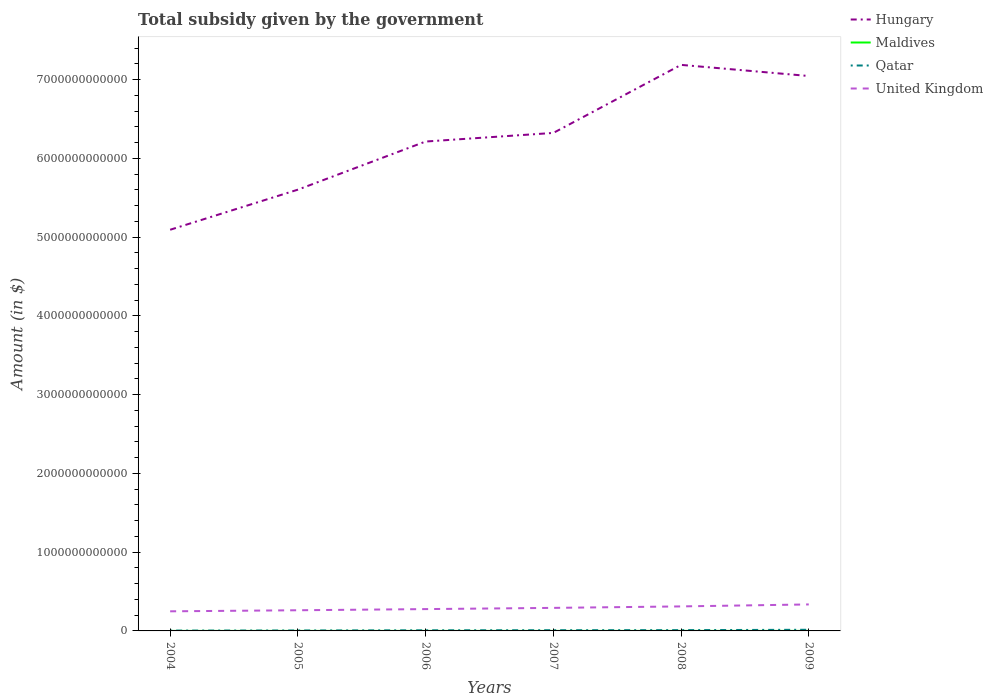How many different coloured lines are there?
Offer a terse response. 4. Does the line corresponding to Maldives intersect with the line corresponding to United Kingdom?
Give a very brief answer. No. Across all years, what is the maximum total revenue collected by the government in Hungary?
Offer a terse response. 5.09e+12. What is the total total revenue collected by the government in United Kingdom in the graph?
Offer a terse response. -3.41e+1. What is the difference between the highest and the second highest total revenue collected by the government in Qatar?
Your answer should be very brief. 1.04e+1. Is the total revenue collected by the government in United Kingdom strictly greater than the total revenue collected by the government in Hungary over the years?
Your response must be concise. Yes. How many lines are there?
Your answer should be very brief. 4. What is the difference between two consecutive major ticks on the Y-axis?
Your response must be concise. 1.00e+12. Are the values on the major ticks of Y-axis written in scientific E-notation?
Offer a terse response. No. Does the graph contain any zero values?
Provide a succinct answer. No. Where does the legend appear in the graph?
Provide a succinct answer. Top right. How many legend labels are there?
Offer a very short reply. 4. What is the title of the graph?
Your answer should be very brief. Total subsidy given by the government. What is the label or title of the X-axis?
Offer a terse response. Years. What is the label or title of the Y-axis?
Keep it short and to the point. Amount (in $). What is the Amount (in $) in Hungary in 2004?
Keep it short and to the point. 5.09e+12. What is the Amount (in $) in Maldives in 2004?
Your answer should be very brief. 4.87e+07. What is the Amount (in $) in Qatar in 2004?
Offer a terse response. 4.11e+09. What is the Amount (in $) in United Kingdom in 2004?
Provide a succinct answer. 2.49e+11. What is the Amount (in $) in Hungary in 2005?
Give a very brief answer. 5.60e+12. What is the Amount (in $) in Maldives in 2005?
Ensure brevity in your answer.  2.28e+08. What is the Amount (in $) in Qatar in 2005?
Your response must be concise. 5.51e+09. What is the Amount (in $) of United Kingdom in 2005?
Offer a very short reply. 2.62e+11. What is the Amount (in $) in Hungary in 2006?
Offer a very short reply. 6.21e+12. What is the Amount (in $) of Maldives in 2006?
Make the answer very short. 1.50e+08. What is the Amount (in $) of Qatar in 2006?
Provide a succinct answer. 7.79e+09. What is the Amount (in $) of United Kingdom in 2006?
Your answer should be compact. 2.77e+11. What is the Amount (in $) in Hungary in 2007?
Provide a short and direct response. 6.32e+12. What is the Amount (in $) of Maldives in 2007?
Your answer should be compact. 1.68e+08. What is the Amount (in $) in Qatar in 2007?
Offer a very short reply. 8.92e+09. What is the Amount (in $) in United Kingdom in 2007?
Give a very brief answer. 2.93e+11. What is the Amount (in $) of Hungary in 2008?
Ensure brevity in your answer.  7.19e+12. What is the Amount (in $) in Maldives in 2008?
Ensure brevity in your answer.  4.79e+08. What is the Amount (in $) of Qatar in 2008?
Provide a short and direct response. 9.95e+09. What is the Amount (in $) of United Kingdom in 2008?
Make the answer very short. 3.11e+11. What is the Amount (in $) of Hungary in 2009?
Offer a terse response. 7.04e+12. What is the Amount (in $) of Maldives in 2009?
Provide a succinct answer. 4.22e+08. What is the Amount (in $) in Qatar in 2009?
Your response must be concise. 1.45e+1. What is the Amount (in $) of United Kingdom in 2009?
Offer a terse response. 3.36e+11. Across all years, what is the maximum Amount (in $) of Hungary?
Give a very brief answer. 7.19e+12. Across all years, what is the maximum Amount (in $) in Maldives?
Give a very brief answer. 4.79e+08. Across all years, what is the maximum Amount (in $) of Qatar?
Offer a very short reply. 1.45e+1. Across all years, what is the maximum Amount (in $) in United Kingdom?
Your response must be concise. 3.36e+11. Across all years, what is the minimum Amount (in $) in Hungary?
Your answer should be very brief. 5.09e+12. Across all years, what is the minimum Amount (in $) in Maldives?
Your answer should be compact. 4.87e+07. Across all years, what is the minimum Amount (in $) in Qatar?
Your answer should be compact. 4.11e+09. Across all years, what is the minimum Amount (in $) of United Kingdom?
Your answer should be very brief. 2.49e+11. What is the total Amount (in $) in Hungary in the graph?
Your answer should be compact. 3.75e+13. What is the total Amount (in $) in Maldives in the graph?
Offer a very short reply. 1.50e+09. What is the total Amount (in $) in Qatar in the graph?
Your answer should be very brief. 5.08e+1. What is the total Amount (in $) of United Kingdom in the graph?
Provide a succinct answer. 1.73e+12. What is the difference between the Amount (in $) in Hungary in 2004 and that in 2005?
Provide a succinct answer. -5.09e+11. What is the difference between the Amount (in $) in Maldives in 2004 and that in 2005?
Offer a very short reply. -1.79e+08. What is the difference between the Amount (in $) in Qatar in 2004 and that in 2005?
Keep it short and to the point. -1.41e+09. What is the difference between the Amount (in $) in United Kingdom in 2004 and that in 2005?
Make the answer very short. -1.35e+1. What is the difference between the Amount (in $) in Hungary in 2004 and that in 2006?
Your response must be concise. -1.12e+12. What is the difference between the Amount (in $) in Maldives in 2004 and that in 2006?
Make the answer very short. -1.01e+08. What is the difference between the Amount (in $) in Qatar in 2004 and that in 2006?
Offer a terse response. -3.68e+09. What is the difference between the Amount (in $) in United Kingdom in 2004 and that in 2006?
Ensure brevity in your answer.  -2.82e+1. What is the difference between the Amount (in $) in Hungary in 2004 and that in 2007?
Your answer should be very brief. -1.23e+12. What is the difference between the Amount (in $) of Maldives in 2004 and that in 2007?
Provide a succinct answer. -1.20e+08. What is the difference between the Amount (in $) of Qatar in 2004 and that in 2007?
Provide a short and direct response. -4.81e+09. What is the difference between the Amount (in $) of United Kingdom in 2004 and that in 2007?
Your response must be concise. -4.36e+1. What is the difference between the Amount (in $) of Hungary in 2004 and that in 2008?
Your answer should be very brief. -2.09e+12. What is the difference between the Amount (in $) in Maldives in 2004 and that in 2008?
Make the answer very short. -4.30e+08. What is the difference between the Amount (in $) of Qatar in 2004 and that in 2008?
Offer a terse response. -5.85e+09. What is the difference between the Amount (in $) in United Kingdom in 2004 and that in 2008?
Your answer should be compact. -6.22e+1. What is the difference between the Amount (in $) in Hungary in 2004 and that in 2009?
Provide a short and direct response. -1.95e+12. What is the difference between the Amount (in $) of Maldives in 2004 and that in 2009?
Provide a short and direct response. -3.73e+08. What is the difference between the Amount (in $) of Qatar in 2004 and that in 2009?
Your response must be concise. -1.04e+1. What is the difference between the Amount (in $) of United Kingdom in 2004 and that in 2009?
Offer a very short reply. -8.75e+1. What is the difference between the Amount (in $) in Hungary in 2005 and that in 2006?
Give a very brief answer. -6.11e+11. What is the difference between the Amount (in $) in Maldives in 2005 and that in 2006?
Make the answer very short. 7.77e+07. What is the difference between the Amount (in $) of Qatar in 2005 and that in 2006?
Give a very brief answer. -2.28e+09. What is the difference between the Amount (in $) in United Kingdom in 2005 and that in 2006?
Ensure brevity in your answer.  -1.46e+1. What is the difference between the Amount (in $) of Hungary in 2005 and that in 2007?
Keep it short and to the point. -7.20e+11. What is the difference between the Amount (in $) in Maldives in 2005 and that in 2007?
Your answer should be compact. 5.92e+07. What is the difference between the Amount (in $) of Qatar in 2005 and that in 2007?
Provide a succinct answer. -3.41e+09. What is the difference between the Amount (in $) of United Kingdom in 2005 and that in 2007?
Make the answer very short. -3.01e+1. What is the difference between the Amount (in $) of Hungary in 2005 and that in 2008?
Give a very brief answer. -1.58e+12. What is the difference between the Amount (in $) of Maldives in 2005 and that in 2008?
Your answer should be very brief. -2.52e+08. What is the difference between the Amount (in $) in Qatar in 2005 and that in 2008?
Your answer should be very brief. -4.44e+09. What is the difference between the Amount (in $) of United Kingdom in 2005 and that in 2008?
Offer a terse response. -4.87e+1. What is the difference between the Amount (in $) in Hungary in 2005 and that in 2009?
Ensure brevity in your answer.  -1.44e+12. What is the difference between the Amount (in $) of Maldives in 2005 and that in 2009?
Your response must be concise. -1.94e+08. What is the difference between the Amount (in $) of Qatar in 2005 and that in 2009?
Make the answer very short. -9.03e+09. What is the difference between the Amount (in $) in United Kingdom in 2005 and that in 2009?
Make the answer very short. -7.39e+1. What is the difference between the Amount (in $) in Hungary in 2006 and that in 2007?
Give a very brief answer. -1.09e+11. What is the difference between the Amount (in $) in Maldives in 2006 and that in 2007?
Your answer should be very brief. -1.85e+07. What is the difference between the Amount (in $) in Qatar in 2006 and that in 2007?
Provide a short and direct response. -1.13e+09. What is the difference between the Amount (in $) of United Kingdom in 2006 and that in 2007?
Your response must be concise. -1.55e+1. What is the difference between the Amount (in $) in Hungary in 2006 and that in 2008?
Keep it short and to the point. -9.73e+11. What is the difference between the Amount (in $) of Maldives in 2006 and that in 2008?
Your answer should be very brief. -3.29e+08. What is the difference between the Amount (in $) in Qatar in 2006 and that in 2008?
Your answer should be very brief. -2.16e+09. What is the difference between the Amount (in $) of United Kingdom in 2006 and that in 2008?
Make the answer very short. -3.41e+1. What is the difference between the Amount (in $) in Hungary in 2006 and that in 2009?
Your answer should be very brief. -8.32e+11. What is the difference between the Amount (in $) of Maldives in 2006 and that in 2009?
Offer a very short reply. -2.72e+08. What is the difference between the Amount (in $) in Qatar in 2006 and that in 2009?
Make the answer very short. -6.75e+09. What is the difference between the Amount (in $) in United Kingdom in 2006 and that in 2009?
Make the answer very short. -5.93e+1. What is the difference between the Amount (in $) in Hungary in 2007 and that in 2008?
Keep it short and to the point. -8.64e+11. What is the difference between the Amount (in $) in Maldives in 2007 and that in 2008?
Keep it short and to the point. -3.11e+08. What is the difference between the Amount (in $) of Qatar in 2007 and that in 2008?
Your answer should be very brief. -1.03e+09. What is the difference between the Amount (in $) in United Kingdom in 2007 and that in 2008?
Your answer should be compact. -1.86e+1. What is the difference between the Amount (in $) in Hungary in 2007 and that in 2009?
Provide a short and direct response. -7.23e+11. What is the difference between the Amount (in $) of Maldives in 2007 and that in 2009?
Offer a terse response. -2.53e+08. What is the difference between the Amount (in $) in Qatar in 2007 and that in 2009?
Offer a terse response. -5.62e+09. What is the difference between the Amount (in $) of United Kingdom in 2007 and that in 2009?
Your answer should be compact. -4.38e+1. What is the difference between the Amount (in $) in Hungary in 2008 and that in 2009?
Your answer should be compact. 1.41e+11. What is the difference between the Amount (in $) of Maldives in 2008 and that in 2009?
Offer a very short reply. 5.76e+07. What is the difference between the Amount (in $) of Qatar in 2008 and that in 2009?
Provide a short and direct response. -4.59e+09. What is the difference between the Amount (in $) of United Kingdom in 2008 and that in 2009?
Provide a succinct answer. -2.52e+1. What is the difference between the Amount (in $) of Hungary in 2004 and the Amount (in $) of Maldives in 2005?
Provide a succinct answer. 5.09e+12. What is the difference between the Amount (in $) in Hungary in 2004 and the Amount (in $) in Qatar in 2005?
Your answer should be very brief. 5.09e+12. What is the difference between the Amount (in $) of Hungary in 2004 and the Amount (in $) of United Kingdom in 2005?
Offer a terse response. 4.83e+12. What is the difference between the Amount (in $) of Maldives in 2004 and the Amount (in $) of Qatar in 2005?
Your answer should be very brief. -5.46e+09. What is the difference between the Amount (in $) in Maldives in 2004 and the Amount (in $) in United Kingdom in 2005?
Ensure brevity in your answer.  -2.62e+11. What is the difference between the Amount (in $) of Qatar in 2004 and the Amount (in $) of United Kingdom in 2005?
Offer a very short reply. -2.58e+11. What is the difference between the Amount (in $) in Hungary in 2004 and the Amount (in $) in Maldives in 2006?
Ensure brevity in your answer.  5.09e+12. What is the difference between the Amount (in $) of Hungary in 2004 and the Amount (in $) of Qatar in 2006?
Ensure brevity in your answer.  5.09e+12. What is the difference between the Amount (in $) of Hungary in 2004 and the Amount (in $) of United Kingdom in 2006?
Offer a terse response. 4.82e+12. What is the difference between the Amount (in $) of Maldives in 2004 and the Amount (in $) of Qatar in 2006?
Offer a very short reply. -7.74e+09. What is the difference between the Amount (in $) of Maldives in 2004 and the Amount (in $) of United Kingdom in 2006?
Provide a succinct answer. -2.77e+11. What is the difference between the Amount (in $) of Qatar in 2004 and the Amount (in $) of United Kingdom in 2006?
Give a very brief answer. -2.73e+11. What is the difference between the Amount (in $) in Hungary in 2004 and the Amount (in $) in Maldives in 2007?
Your answer should be compact. 5.09e+12. What is the difference between the Amount (in $) in Hungary in 2004 and the Amount (in $) in Qatar in 2007?
Provide a succinct answer. 5.08e+12. What is the difference between the Amount (in $) in Hungary in 2004 and the Amount (in $) in United Kingdom in 2007?
Make the answer very short. 4.80e+12. What is the difference between the Amount (in $) of Maldives in 2004 and the Amount (in $) of Qatar in 2007?
Ensure brevity in your answer.  -8.87e+09. What is the difference between the Amount (in $) of Maldives in 2004 and the Amount (in $) of United Kingdom in 2007?
Your answer should be compact. -2.92e+11. What is the difference between the Amount (in $) of Qatar in 2004 and the Amount (in $) of United Kingdom in 2007?
Provide a succinct answer. -2.88e+11. What is the difference between the Amount (in $) of Hungary in 2004 and the Amount (in $) of Maldives in 2008?
Make the answer very short. 5.09e+12. What is the difference between the Amount (in $) in Hungary in 2004 and the Amount (in $) in Qatar in 2008?
Ensure brevity in your answer.  5.08e+12. What is the difference between the Amount (in $) of Hungary in 2004 and the Amount (in $) of United Kingdom in 2008?
Your answer should be compact. 4.78e+12. What is the difference between the Amount (in $) of Maldives in 2004 and the Amount (in $) of Qatar in 2008?
Give a very brief answer. -9.90e+09. What is the difference between the Amount (in $) of Maldives in 2004 and the Amount (in $) of United Kingdom in 2008?
Give a very brief answer. -3.11e+11. What is the difference between the Amount (in $) in Qatar in 2004 and the Amount (in $) in United Kingdom in 2008?
Offer a very short reply. -3.07e+11. What is the difference between the Amount (in $) of Hungary in 2004 and the Amount (in $) of Maldives in 2009?
Keep it short and to the point. 5.09e+12. What is the difference between the Amount (in $) in Hungary in 2004 and the Amount (in $) in Qatar in 2009?
Your answer should be very brief. 5.08e+12. What is the difference between the Amount (in $) in Hungary in 2004 and the Amount (in $) in United Kingdom in 2009?
Your answer should be compact. 4.76e+12. What is the difference between the Amount (in $) in Maldives in 2004 and the Amount (in $) in Qatar in 2009?
Offer a very short reply. -1.45e+1. What is the difference between the Amount (in $) in Maldives in 2004 and the Amount (in $) in United Kingdom in 2009?
Your answer should be compact. -3.36e+11. What is the difference between the Amount (in $) in Qatar in 2004 and the Amount (in $) in United Kingdom in 2009?
Your answer should be very brief. -3.32e+11. What is the difference between the Amount (in $) of Hungary in 2005 and the Amount (in $) of Maldives in 2006?
Keep it short and to the point. 5.60e+12. What is the difference between the Amount (in $) in Hungary in 2005 and the Amount (in $) in Qatar in 2006?
Keep it short and to the point. 5.59e+12. What is the difference between the Amount (in $) in Hungary in 2005 and the Amount (in $) in United Kingdom in 2006?
Provide a succinct answer. 5.32e+12. What is the difference between the Amount (in $) in Maldives in 2005 and the Amount (in $) in Qatar in 2006?
Provide a short and direct response. -7.56e+09. What is the difference between the Amount (in $) of Maldives in 2005 and the Amount (in $) of United Kingdom in 2006?
Ensure brevity in your answer.  -2.77e+11. What is the difference between the Amount (in $) of Qatar in 2005 and the Amount (in $) of United Kingdom in 2006?
Keep it short and to the point. -2.72e+11. What is the difference between the Amount (in $) of Hungary in 2005 and the Amount (in $) of Maldives in 2007?
Your answer should be compact. 5.60e+12. What is the difference between the Amount (in $) of Hungary in 2005 and the Amount (in $) of Qatar in 2007?
Offer a terse response. 5.59e+12. What is the difference between the Amount (in $) of Hungary in 2005 and the Amount (in $) of United Kingdom in 2007?
Keep it short and to the point. 5.31e+12. What is the difference between the Amount (in $) in Maldives in 2005 and the Amount (in $) in Qatar in 2007?
Your answer should be compact. -8.69e+09. What is the difference between the Amount (in $) in Maldives in 2005 and the Amount (in $) in United Kingdom in 2007?
Make the answer very short. -2.92e+11. What is the difference between the Amount (in $) of Qatar in 2005 and the Amount (in $) of United Kingdom in 2007?
Offer a very short reply. -2.87e+11. What is the difference between the Amount (in $) in Hungary in 2005 and the Amount (in $) in Maldives in 2008?
Offer a terse response. 5.60e+12. What is the difference between the Amount (in $) in Hungary in 2005 and the Amount (in $) in Qatar in 2008?
Your response must be concise. 5.59e+12. What is the difference between the Amount (in $) in Hungary in 2005 and the Amount (in $) in United Kingdom in 2008?
Your answer should be compact. 5.29e+12. What is the difference between the Amount (in $) in Maldives in 2005 and the Amount (in $) in Qatar in 2008?
Ensure brevity in your answer.  -9.73e+09. What is the difference between the Amount (in $) of Maldives in 2005 and the Amount (in $) of United Kingdom in 2008?
Your answer should be very brief. -3.11e+11. What is the difference between the Amount (in $) of Qatar in 2005 and the Amount (in $) of United Kingdom in 2008?
Ensure brevity in your answer.  -3.06e+11. What is the difference between the Amount (in $) in Hungary in 2005 and the Amount (in $) in Maldives in 2009?
Your answer should be very brief. 5.60e+12. What is the difference between the Amount (in $) of Hungary in 2005 and the Amount (in $) of Qatar in 2009?
Give a very brief answer. 5.59e+12. What is the difference between the Amount (in $) in Hungary in 2005 and the Amount (in $) in United Kingdom in 2009?
Your answer should be very brief. 5.27e+12. What is the difference between the Amount (in $) of Maldives in 2005 and the Amount (in $) of Qatar in 2009?
Provide a short and direct response. -1.43e+1. What is the difference between the Amount (in $) in Maldives in 2005 and the Amount (in $) in United Kingdom in 2009?
Offer a terse response. -3.36e+11. What is the difference between the Amount (in $) of Qatar in 2005 and the Amount (in $) of United Kingdom in 2009?
Your answer should be very brief. -3.31e+11. What is the difference between the Amount (in $) of Hungary in 2006 and the Amount (in $) of Maldives in 2007?
Your answer should be compact. 6.21e+12. What is the difference between the Amount (in $) in Hungary in 2006 and the Amount (in $) in Qatar in 2007?
Your answer should be compact. 6.20e+12. What is the difference between the Amount (in $) in Hungary in 2006 and the Amount (in $) in United Kingdom in 2007?
Provide a short and direct response. 5.92e+12. What is the difference between the Amount (in $) in Maldives in 2006 and the Amount (in $) in Qatar in 2007?
Give a very brief answer. -8.77e+09. What is the difference between the Amount (in $) of Maldives in 2006 and the Amount (in $) of United Kingdom in 2007?
Your response must be concise. -2.92e+11. What is the difference between the Amount (in $) of Qatar in 2006 and the Amount (in $) of United Kingdom in 2007?
Offer a terse response. -2.85e+11. What is the difference between the Amount (in $) of Hungary in 2006 and the Amount (in $) of Maldives in 2008?
Offer a terse response. 6.21e+12. What is the difference between the Amount (in $) of Hungary in 2006 and the Amount (in $) of Qatar in 2008?
Offer a terse response. 6.20e+12. What is the difference between the Amount (in $) of Hungary in 2006 and the Amount (in $) of United Kingdom in 2008?
Your answer should be very brief. 5.90e+12. What is the difference between the Amount (in $) of Maldives in 2006 and the Amount (in $) of Qatar in 2008?
Offer a very short reply. -9.80e+09. What is the difference between the Amount (in $) of Maldives in 2006 and the Amount (in $) of United Kingdom in 2008?
Give a very brief answer. -3.11e+11. What is the difference between the Amount (in $) of Qatar in 2006 and the Amount (in $) of United Kingdom in 2008?
Offer a very short reply. -3.03e+11. What is the difference between the Amount (in $) of Hungary in 2006 and the Amount (in $) of Maldives in 2009?
Your answer should be very brief. 6.21e+12. What is the difference between the Amount (in $) of Hungary in 2006 and the Amount (in $) of Qatar in 2009?
Keep it short and to the point. 6.20e+12. What is the difference between the Amount (in $) in Hungary in 2006 and the Amount (in $) in United Kingdom in 2009?
Keep it short and to the point. 5.88e+12. What is the difference between the Amount (in $) in Maldives in 2006 and the Amount (in $) in Qatar in 2009?
Provide a short and direct response. -1.44e+1. What is the difference between the Amount (in $) in Maldives in 2006 and the Amount (in $) in United Kingdom in 2009?
Offer a terse response. -3.36e+11. What is the difference between the Amount (in $) of Qatar in 2006 and the Amount (in $) of United Kingdom in 2009?
Your answer should be very brief. -3.29e+11. What is the difference between the Amount (in $) in Hungary in 2007 and the Amount (in $) in Maldives in 2008?
Your answer should be very brief. 6.32e+12. What is the difference between the Amount (in $) of Hungary in 2007 and the Amount (in $) of Qatar in 2008?
Give a very brief answer. 6.31e+12. What is the difference between the Amount (in $) in Hungary in 2007 and the Amount (in $) in United Kingdom in 2008?
Give a very brief answer. 6.01e+12. What is the difference between the Amount (in $) in Maldives in 2007 and the Amount (in $) in Qatar in 2008?
Provide a short and direct response. -9.79e+09. What is the difference between the Amount (in $) in Maldives in 2007 and the Amount (in $) in United Kingdom in 2008?
Keep it short and to the point. -3.11e+11. What is the difference between the Amount (in $) of Qatar in 2007 and the Amount (in $) of United Kingdom in 2008?
Offer a terse response. -3.02e+11. What is the difference between the Amount (in $) of Hungary in 2007 and the Amount (in $) of Maldives in 2009?
Your answer should be very brief. 6.32e+12. What is the difference between the Amount (in $) in Hungary in 2007 and the Amount (in $) in Qatar in 2009?
Your answer should be very brief. 6.31e+12. What is the difference between the Amount (in $) in Hungary in 2007 and the Amount (in $) in United Kingdom in 2009?
Make the answer very short. 5.99e+12. What is the difference between the Amount (in $) of Maldives in 2007 and the Amount (in $) of Qatar in 2009?
Offer a terse response. -1.44e+1. What is the difference between the Amount (in $) of Maldives in 2007 and the Amount (in $) of United Kingdom in 2009?
Provide a succinct answer. -3.36e+11. What is the difference between the Amount (in $) in Qatar in 2007 and the Amount (in $) in United Kingdom in 2009?
Provide a short and direct response. -3.27e+11. What is the difference between the Amount (in $) in Hungary in 2008 and the Amount (in $) in Maldives in 2009?
Provide a short and direct response. 7.19e+12. What is the difference between the Amount (in $) of Hungary in 2008 and the Amount (in $) of Qatar in 2009?
Ensure brevity in your answer.  7.17e+12. What is the difference between the Amount (in $) of Hungary in 2008 and the Amount (in $) of United Kingdom in 2009?
Your response must be concise. 6.85e+12. What is the difference between the Amount (in $) of Maldives in 2008 and the Amount (in $) of Qatar in 2009?
Offer a terse response. -1.41e+1. What is the difference between the Amount (in $) of Maldives in 2008 and the Amount (in $) of United Kingdom in 2009?
Your response must be concise. -3.36e+11. What is the difference between the Amount (in $) in Qatar in 2008 and the Amount (in $) in United Kingdom in 2009?
Provide a short and direct response. -3.26e+11. What is the average Amount (in $) in Hungary per year?
Give a very brief answer. 6.24e+12. What is the average Amount (in $) of Maldives per year?
Offer a terse response. 2.49e+08. What is the average Amount (in $) in Qatar per year?
Ensure brevity in your answer.  8.47e+09. What is the average Amount (in $) of United Kingdom per year?
Offer a terse response. 2.88e+11. In the year 2004, what is the difference between the Amount (in $) in Hungary and Amount (in $) in Maldives?
Offer a very short reply. 5.09e+12. In the year 2004, what is the difference between the Amount (in $) in Hungary and Amount (in $) in Qatar?
Provide a succinct answer. 5.09e+12. In the year 2004, what is the difference between the Amount (in $) of Hungary and Amount (in $) of United Kingdom?
Keep it short and to the point. 4.84e+12. In the year 2004, what is the difference between the Amount (in $) in Maldives and Amount (in $) in Qatar?
Offer a terse response. -4.06e+09. In the year 2004, what is the difference between the Amount (in $) in Maldives and Amount (in $) in United Kingdom?
Give a very brief answer. -2.49e+11. In the year 2004, what is the difference between the Amount (in $) in Qatar and Amount (in $) in United Kingdom?
Ensure brevity in your answer.  -2.45e+11. In the year 2005, what is the difference between the Amount (in $) of Hungary and Amount (in $) of Maldives?
Offer a terse response. 5.60e+12. In the year 2005, what is the difference between the Amount (in $) in Hungary and Amount (in $) in Qatar?
Provide a succinct answer. 5.60e+12. In the year 2005, what is the difference between the Amount (in $) in Hungary and Amount (in $) in United Kingdom?
Provide a succinct answer. 5.34e+12. In the year 2005, what is the difference between the Amount (in $) of Maldives and Amount (in $) of Qatar?
Your response must be concise. -5.28e+09. In the year 2005, what is the difference between the Amount (in $) in Maldives and Amount (in $) in United Kingdom?
Your response must be concise. -2.62e+11. In the year 2005, what is the difference between the Amount (in $) of Qatar and Amount (in $) of United Kingdom?
Offer a terse response. -2.57e+11. In the year 2006, what is the difference between the Amount (in $) in Hungary and Amount (in $) in Maldives?
Keep it short and to the point. 6.21e+12. In the year 2006, what is the difference between the Amount (in $) in Hungary and Amount (in $) in Qatar?
Make the answer very short. 6.21e+12. In the year 2006, what is the difference between the Amount (in $) in Hungary and Amount (in $) in United Kingdom?
Offer a terse response. 5.94e+12. In the year 2006, what is the difference between the Amount (in $) of Maldives and Amount (in $) of Qatar?
Your response must be concise. -7.64e+09. In the year 2006, what is the difference between the Amount (in $) of Maldives and Amount (in $) of United Kingdom?
Provide a short and direct response. -2.77e+11. In the year 2006, what is the difference between the Amount (in $) in Qatar and Amount (in $) in United Kingdom?
Offer a very short reply. -2.69e+11. In the year 2007, what is the difference between the Amount (in $) in Hungary and Amount (in $) in Maldives?
Offer a terse response. 6.32e+12. In the year 2007, what is the difference between the Amount (in $) in Hungary and Amount (in $) in Qatar?
Give a very brief answer. 6.31e+12. In the year 2007, what is the difference between the Amount (in $) of Hungary and Amount (in $) of United Kingdom?
Your response must be concise. 6.03e+12. In the year 2007, what is the difference between the Amount (in $) of Maldives and Amount (in $) of Qatar?
Offer a very short reply. -8.75e+09. In the year 2007, what is the difference between the Amount (in $) of Maldives and Amount (in $) of United Kingdom?
Ensure brevity in your answer.  -2.92e+11. In the year 2007, what is the difference between the Amount (in $) of Qatar and Amount (in $) of United Kingdom?
Give a very brief answer. -2.84e+11. In the year 2008, what is the difference between the Amount (in $) of Hungary and Amount (in $) of Maldives?
Give a very brief answer. 7.19e+12. In the year 2008, what is the difference between the Amount (in $) in Hungary and Amount (in $) in Qatar?
Your response must be concise. 7.18e+12. In the year 2008, what is the difference between the Amount (in $) in Hungary and Amount (in $) in United Kingdom?
Offer a terse response. 6.87e+12. In the year 2008, what is the difference between the Amount (in $) of Maldives and Amount (in $) of Qatar?
Give a very brief answer. -9.47e+09. In the year 2008, what is the difference between the Amount (in $) in Maldives and Amount (in $) in United Kingdom?
Provide a short and direct response. -3.11e+11. In the year 2008, what is the difference between the Amount (in $) in Qatar and Amount (in $) in United Kingdom?
Provide a succinct answer. -3.01e+11. In the year 2009, what is the difference between the Amount (in $) of Hungary and Amount (in $) of Maldives?
Your answer should be very brief. 7.04e+12. In the year 2009, what is the difference between the Amount (in $) of Hungary and Amount (in $) of Qatar?
Offer a very short reply. 7.03e+12. In the year 2009, what is the difference between the Amount (in $) in Hungary and Amount (in $) in United Kingdom?
Offer a terse response. 6.71e+12. In the year 2009, what is the difference between the Amount (in $) in Maldives and Amount (in $) in Qatar?
Your answer should be compact. -1.41e+1. In the year 2009, what is the difference between the Amount (in $) in Maldives and Amount (in $) in United Kingdom?
Offer a very short reply. -3.36e+11. In the year 2009, what is the difference between the Amount (in $) in Qatar and Amount (in $) in United Kingdom?
Give a very brief answer. -3.22e+11. What is the ratio of the Amount (in $) of Hungary in 2004 to that in 2005?
Make the answer very short. 0.91. What is the ratio of the Amount (in $) in Maldives in 2004 to that in 2005?
Your answer should be very brief. 0.21. What is the ratio of the Amount (in $) in Qatar in 2004 to that in 2005?
Provide a succinct answer. 0.74. What is the ratio of the Amount (in $) in United Kingdom in 2004 to that in 2005?
Your answer should be very brief. 0.95. What is the ratio of the Amount (in $) of Hungary in 2004 to that in 2006?
Your answer should be very brief. 0.82. What is the ratio of the Amount (in $) of Maldives in 2004 to that in 2006?
Your answer should be compact. 0.33. What is the ratio of the Amount (in $) of Qatar in 2004 to that in 2006?
Provide a short and direct response. 0.53. What is the ratio of the Amount (in $) in United Kingdom in 2004 to that in 2006?
Provide a short and direct response. 0.9. What is the ratio of the Amount (in $) of Hungary in 2004 to that in 2007?
Keep it short and to the point. 0.81. What is the ratio of the Amount (in $) of Maldives in 2004 to that in 2007?
Your answer should be very brief. 0.29. What is the ratio of the Amount (in $) in Qatar in 2004 to that in 2007?
Give a very brief answer. 0.46. What is the ratio of the Amount (in $) of United Kingdom in 2004 to that in 2007?
Provide a short and direct response. 0.85. What is the ratio of the Amount (in $) in Hungary in 2004 to that in 2008?
Offer a terse response. 0.71. What is the ratio of the Amount (in $) in Maldives in 2004 to that in 2008?
Your answer should be very brief. 0.1. What is the ratio of the Amount (in $) of Qatar in 2004 to that in 2008?
Your response must be concise. 0.41. What is the ratio of the Amount (in $) in United Kingdom in 2004 to that in 2008?
Make the answer very short. 0.8. What is the ratio of the Amount (in $) in Hungary in 2004 to that in 2009?
Give a very brief answer. 0.72. What is the ratio of the Amount (in $) in Maldives in 2004 to that in 2009?
Give a very brief answer. 0.12. What is the ratio of the Amount (in $) in Qatar in 2004 to that in 2009?
Give a very brief answer. 0.28. What is the ratio of the Amount (in $) in United Kingdom in 2004 to that in 2009?
Keep it short and to the point. 0.74. What is the ratio of the Amount (in $) of Hungary in 2005 to that in 2006?
Offer a terse response. 0.9. What is the ratio of the Amount (in $) in Maldives in 2005 to that in 2006?
Ensure brevity in your answer.  1.52. What is the ratio of the Amount (in $) of Qatar in 2005 to that in 2006?
Keep it short and to the point. 0.71. What is the ratio of the Amount (in $) of United Kingdom in 2005 to that in 2006?
Provide a succinct answer. 0.95. What is the ratio of the Amount (in $) in Hungary in 2005 to that in 2007?
Make the answer very short. 0.89. What is the ratio of the Amount (in $) of Maldives in 2005 to that in 2007?
Ensure brevity in your answer.  1.35. What is the ratio of the Amount (in $) in Qatar in 2005 to that in 2007?
Ensure brevity in your answer.  0.62. What is the ratio of the Amount (in $) of United Kingdom in 2005 to that in 2007?
Your answer should be very brief. 0.9. What is the ratio of the Amount (in $) of Hungary in 2005 to that in 2008?
Provide a short and direct response. 0.78. What is the ratio of the Amount (in $) in Maldives in 2005 to that in 2008?
Your response must be concise. 0.47. What is the ratio of the Amount (in $) of Qatar in 2005 to that in 2008?
Make the answer very short. 0.55. What is the ratio of the Amount (in $) of United Kingdom in 2005 to that in 2008?
Ensure brevity in your answer.  0.84. What is the ratio of the Amount (in $) of Hungary in 2005 to that in 2009?
Your answer should be very brief. 0.8. What is the ratio of the Amount (in $) of Maldives in 2005 to that in 2009?
Make the answer very short. 0.54. What is the ratio of the Amount (in $) in Qatar in 2005 to that in 2009?
Offer a very short reply. 0.38. What is the ratio of the Amount (in $) in United Kingdom in 2005 to that in 2009?
Your answer should be compact. 0.78. What is the ratio of the Amount (in $) of Hungary in 2006 to that in 2007?
Your answer should be very brief. 0.98. What is the ratio of the Amount (in $) of Maldives in 2006 to that in 2007?
Your answer should be compact. 0.89. What is the ratio of the Amount (in $) of Qatar in 2006 to that in 2007?
Give a very brief answer. 0.87. What is the ratio of the Amount (in $) in United Kingdom in 2006 to that in 2007?
Provide a succinct answer. 0.95. What is the ratio of the Amount (in $) in Hungary in 2006 to that in 2008?
Your answer should be compact. 0.86. What is the ratio of the Amount (in $) of Maldives in 2006 to that in 2008?
Give a very brief answer. 0.31. What is the ratio of the Amount (in $) of Qatar in 2006 to that in 2008?
Your answer should be compact. 0.78. What is the ratio of the Amount (in $) of United Kingdom in 2006 to that in 2008?
Keep it short and to the point. 0.89. What is the ratio of the Amount (in $) in Hungary in 2006 to that in 2009?
Ensure brevity in your answer.  0.88. What is the ratio of the Amount (in $) of Maldives in 2006 to that in 2009?
Your response must be concise. 0.36. What is the ratio of the Amount (in $) of Qatar in 2006 to that in 2009?
Your answer should be very brief. 0.54. What is the ratio of the Amount (in $) in United Kingdom in 2006 to that in 2009?
Your answer should be very brief. 0.82. What is the ratio of the Amount (in $) of Hungary in 2007 to that in 2008?
Offer a terse response. 0.88. What is the ratio of the Amount (in $) of Maldives in 2007 to that in 2008?
Offer a very short reply. 0.35. What is the ratio of the Amount (in $) in Qatar in 2007 to that in 2008?
Offer a very short reply. 0.9. What is the ratio of the Amount (in $) in United Kingdom in 2007 to that in 2008?
Ensure brevity in your answer.  0.94. What is the ratio of the Amount (in $) of Hungary in 2007 to that in 2009?
Your response must be concise. 0.9. What is the ratio of the Amount (in $) in Maldives in 2007 to that in 2009?
Your response must be concise. 0.4. What is the ratio of the Amount (in $) of Qatar in 2007 to that in 2009?
Give a very brief answer. 0.61. What is the ratio of the Amount (in $) in United Kingdom in 2007 to that in 2009?
Give a very brief answer. 0.87. What is the ratio of the Amount (in $) of Hungary in 2008 to that in 2009?
Offer a terse response. 1.02. What is the ratio of the Amount (in $) of Maldives in 2008 to that in 2009?
Provide a short and direct response. 1.14. What is the ratio of the Amount (in $) of Qatar in 2008 to that in 2009?
Make the answer very short. 0.68. What is the ratio of the Amount (in $) of United Kingdom in 2008 to that in 2009?
Your answer should be compact. 0.93. What is the difference between the highest and the second highest Amount (in $) in Hungary?
Keep it short and to the point. 1.41e+11. What is the difference between the highest and the second highest Amount (in $) in Maldives?
Provide a succinct answer. 5.76e+07. What is the difference between the highest and the second highest Amount (in $) of Qatar?
Ensure brevity in your answer.  4.59e+09. What is the difference between the highest and the second highest Amount (in $) in United Kingdom?
Offer a very short reply. 2.52e+1. What is the difference between the highest and the lowest Amount (in $) of Hungary?
Make the answer very short. 2.09e+12. What is the difference between the highest and the lowest Amount (in $) in Maldives?
Your answer should be very brief. 4.30e+08. What is the difference between the highest and the lowest Amount (in $) in Qatar?
Offer a terse response. 1.04e+1. What is the difference between the highest and the lowest Amount (in $) of United Kingdom?
Keep it short and to the point. 8.75e+1. 